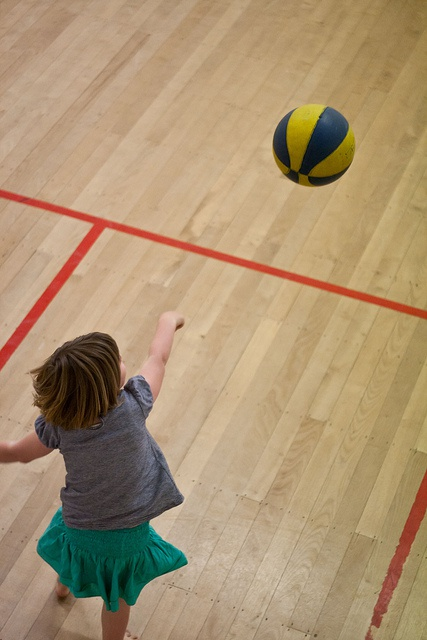Describe the objects in this image and their specific colors. I can see people in gray, black, and teal tones and sports ball in gray, black, and olive tones in this image. 